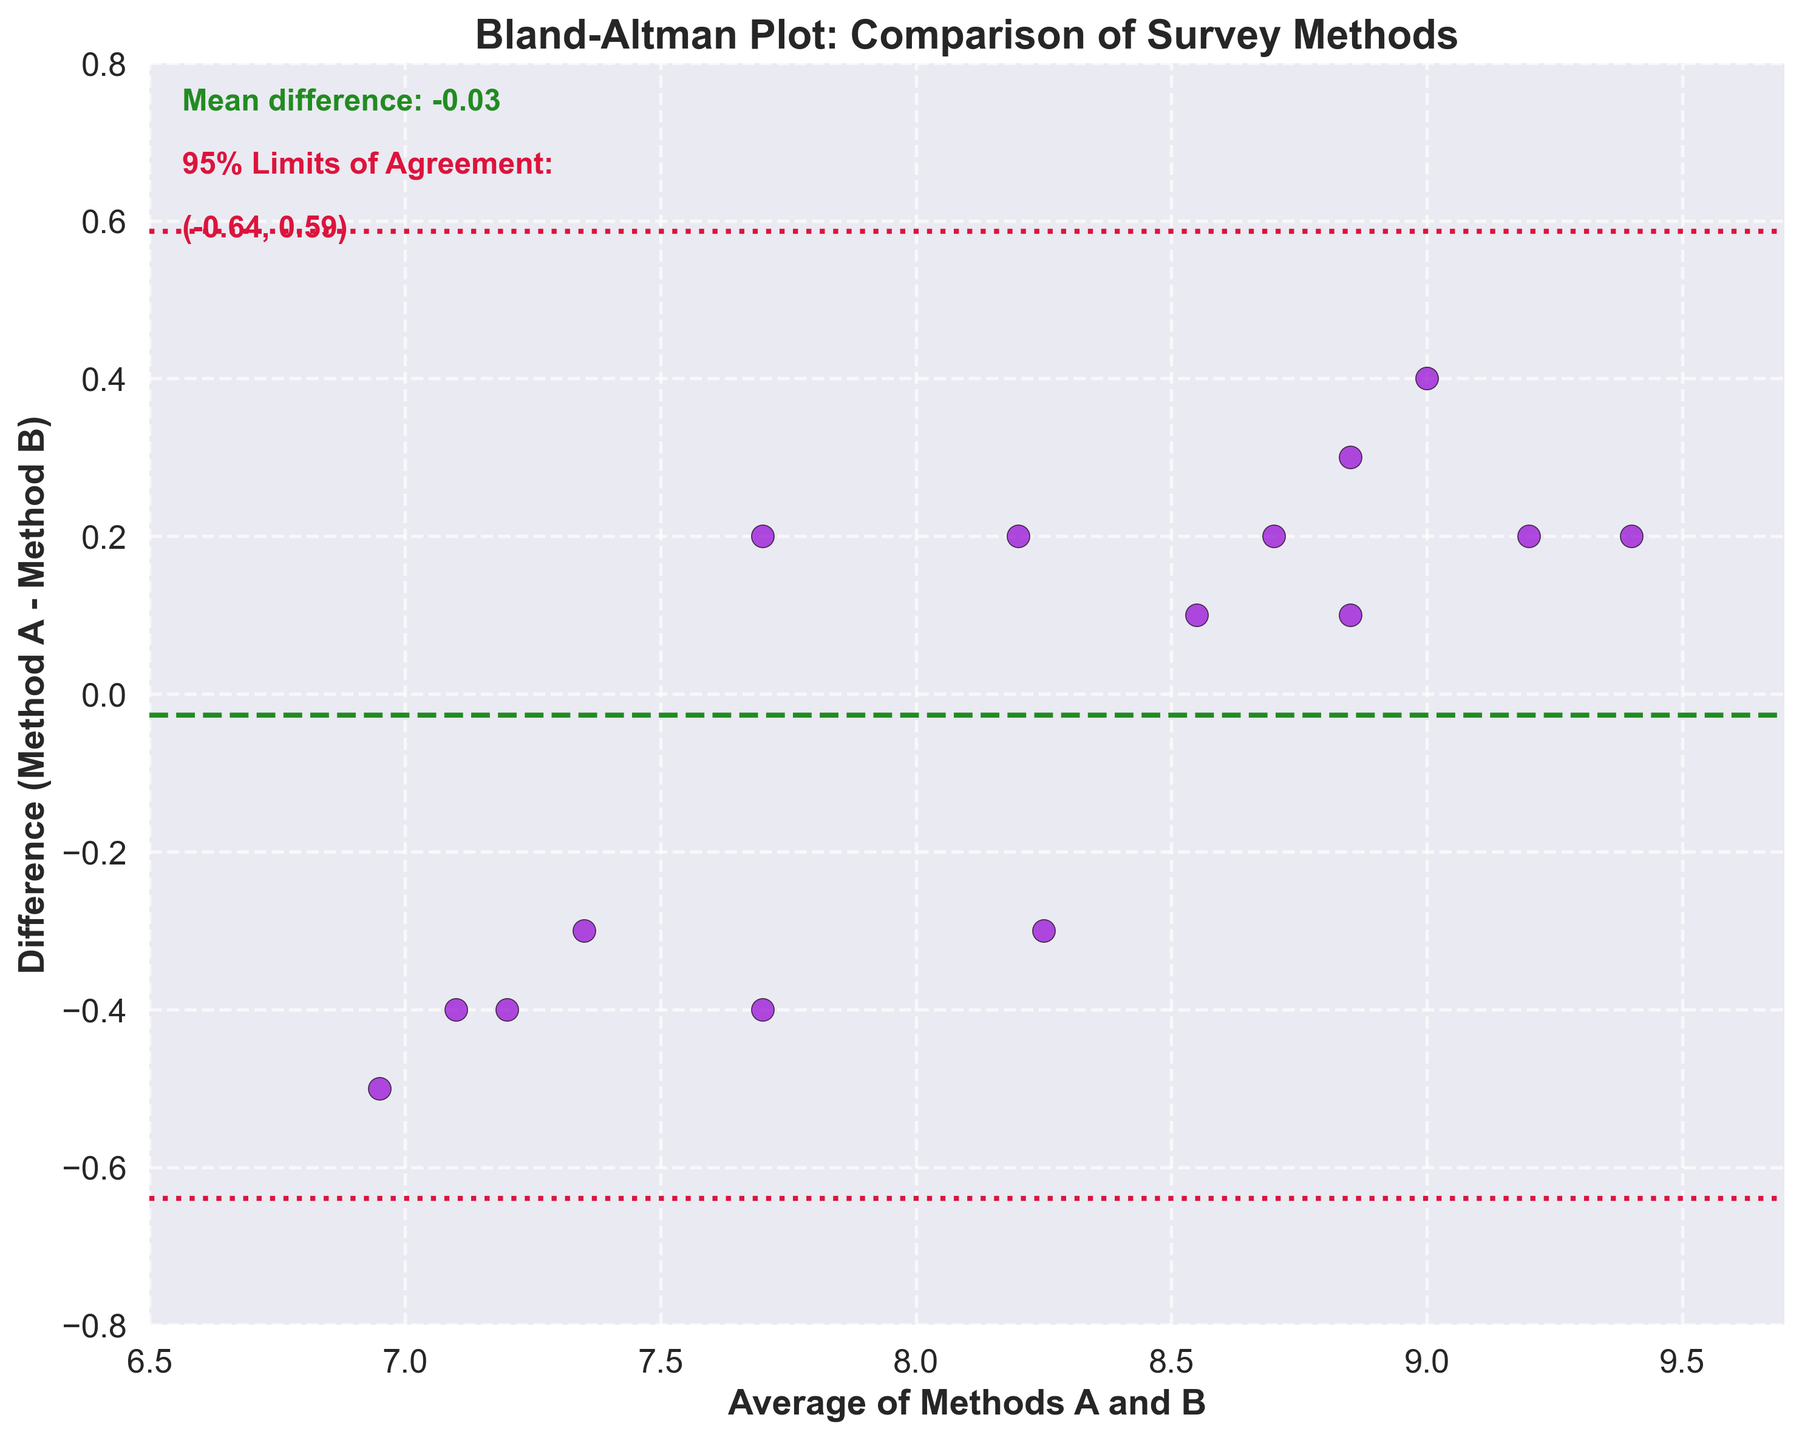What is the title of the plot? The title of the plot is displayed at the top of the figure and directly states the main focus of the analysis. It reads 'Bland-Altman Plot: Comparison of Survey Methods'.
Answer: Bland-Altman Plot: Comparison of Survey Methods What do the x-axis and y-axis labels represent? The x-axis label represents the 'Average of Methods A and B', and the y-axis label represents the 'Difference (Method A - Method B)'. These labels tell us what each axis in the plot measures.
Answer: Average of Methods A and B, Difference (Method A - Method B) How many data points are plotted in the figure? By counting the points, we see that there are 15 data points plotted on the figure. Each point represents a rating comparison between Method A and Method B for a specific customer.
Answer: 15 What is the mean difference between the two methods? The mean difference is shown by the dashed line and is also labeled in the figure's text. It reads 'Mean difference: 0.03'.
Answer: 0.03 What is the purpose of the two dotted lines in the plot? The two dotted lines represent the 95% Limits of Agreement. This means they indicate the range within which 95% of the differences between the two methods fall.
Answer: 95% Limits of Agreement What are the values for the 95% Limits of Agreement? The values are displayed in the figure's text. The lower limit is shown as '(-0.55, 0.61)'. These boundaries indicate where most differences between methods lie.
Answer: (-0.55, 0.61) How many points fall outside the 95% Limits of Agreement? Upon examining the figure, we see that no points are outside the range defined by the dotted lines of the 95% Limits of Agreement.
Answer: 0 Which method tends to give higher ratings, Method A or Method B? As most data points are close to the mean, including slightly positive differences (Mean difference of 0.03), Method A tends to give slightly higher ratings than Method B on average.
Answer: Method A What's the range of average satisfaction ratings in the plot? The x-axis ranges from approximately 6.5 to 9.7, indicating the span of average satisfaction ratings considered in the plot.
Answer: 6.5 to 9.7 If the mean difference was significantly higher, what would that imply regarding the methods? A higher mean difference would imply a systematic bias between the two methods, indicating that one method consistently gives higher ratings than the other.
Answer: Systematic bias if one method's ratings are consistently higher 